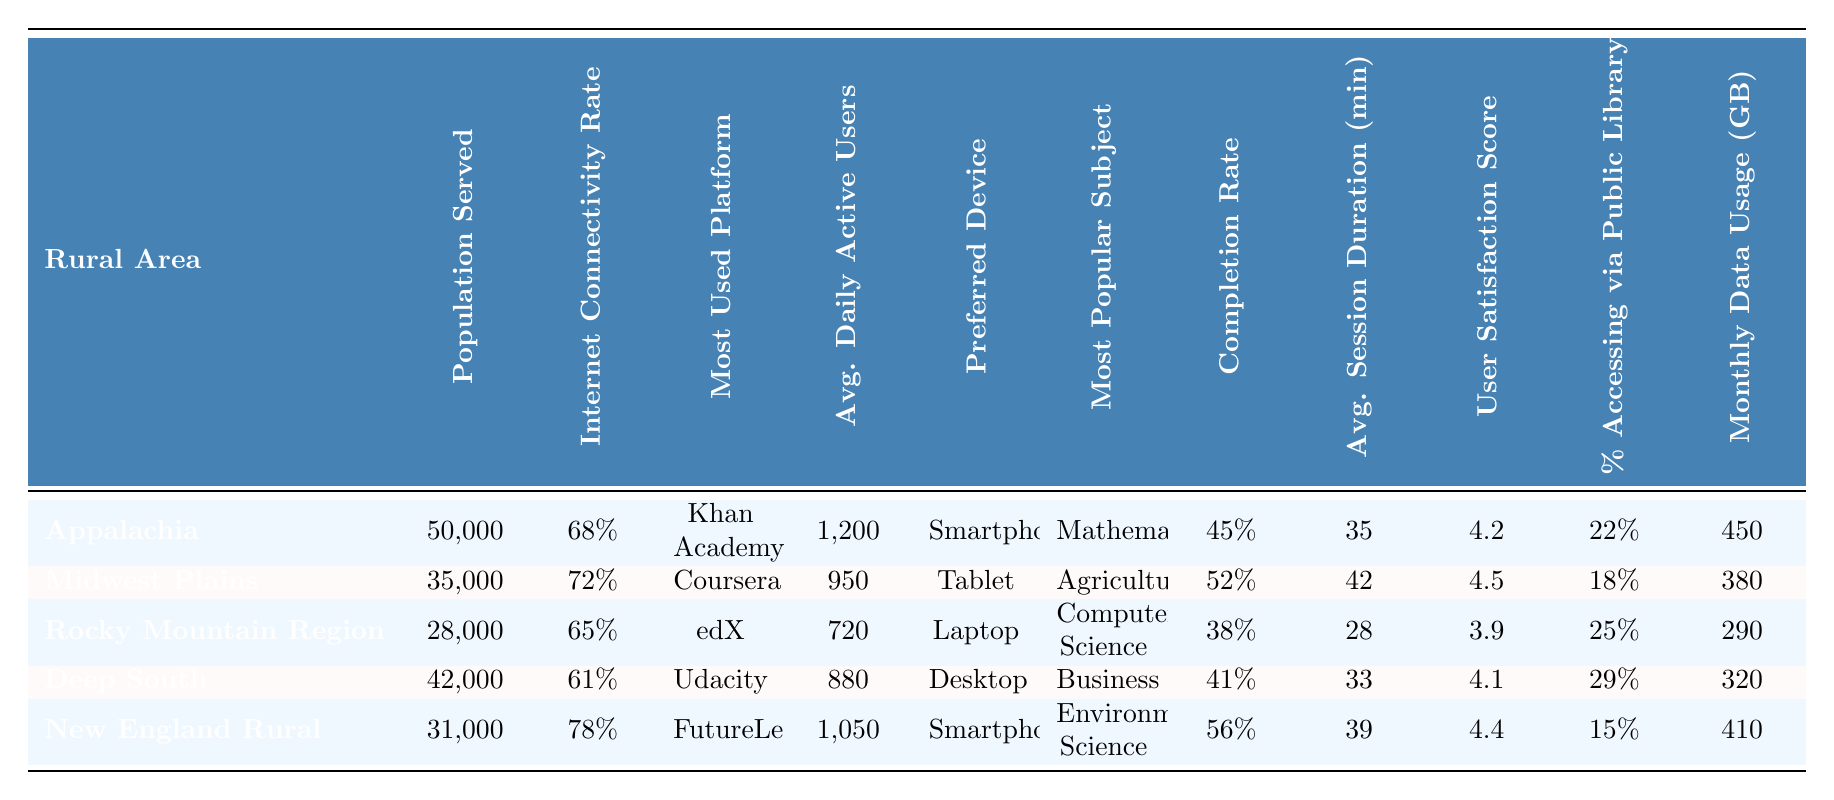What is the Internet connectivity rate for the Midwest Plains? The table lists the Internet connectivity rate for each rural area. For Midwest Plains, it is stated as 72%.
Answer: 72% Which rural area has the highest completion rate? Looking at the completion rates provided for each area, New England Rural has the highest at 56%.
Answer: New England Rural What is the average number of daily active users across all rural areas? To find the average, sum the daily active users (1200 + 950 + 720 + 880 + 1050 = 3800) and divide by the number of areas (5), giving 3800 / 5 = 760.
Answer: 760 Is Khan Academy the most used platform in Appalachia? The table specifies that the most used platform in Appalachia is Khan Academy. Therefore, the answer is yes.
Answer: Yes What is the percentage of users accessing the internet via a public library in the Deep South compared to New England Rural? The Deep South's percentage is 29% and New England Rural's is 15%. When comparing, 29% is greater than 15%, so the Deep South has a higher percentage accessing via public libraries.
Answer: Deep South Which rural area has the lowest average session duration in minutes? The average session durations for the areas are listed as 35, 42, 28, 33, and 39 minutes respectively. Rocky Mountain Region has the lowest at 28 minutes.
Answer: Rocky Mountain Region What is the difference in user satisfaction score between the Midwest Plains and the Rocky Mountain Region? The user satisfaction scores are 4.5 for Midwest Plains and 3.9 for Rocky Mountain Region. The difference is 4.5 - 3.9 = 0.6.
Answer: 0.6 What is the total population served by all five rural areas combined? The total population is the sum of the populations: (50000 + 35000 + 28000 + 42000 + 31000 = 186000).
Answer: 186000 Which platform is most used in the Rocky Mountain Region and what is the average daily active user count there? The most used platform in the Rocky Mountain Region is edX, with an average of 720 daily active users.
Answer: edX, 720 True or False: New England Rural has a higher user satisfaction score than Appalachia. The user satisfaction scores are 4.4 for New England Rural and 4.2 for Appalachia. Since 4.4 is greater than 4.2, this statement is true.
Answer: True Which preferred device is most popular in the Deep South and how does it compare to the preferred devices in the other areas? The preferred device in Deep South is Desktop. Other areas prefer Smartphone, Tablet, or Laptop. The majority choose mobile devices across other regions, indicating a contrast in device preference.
Answer: Desktop, contrast with mobile devices 